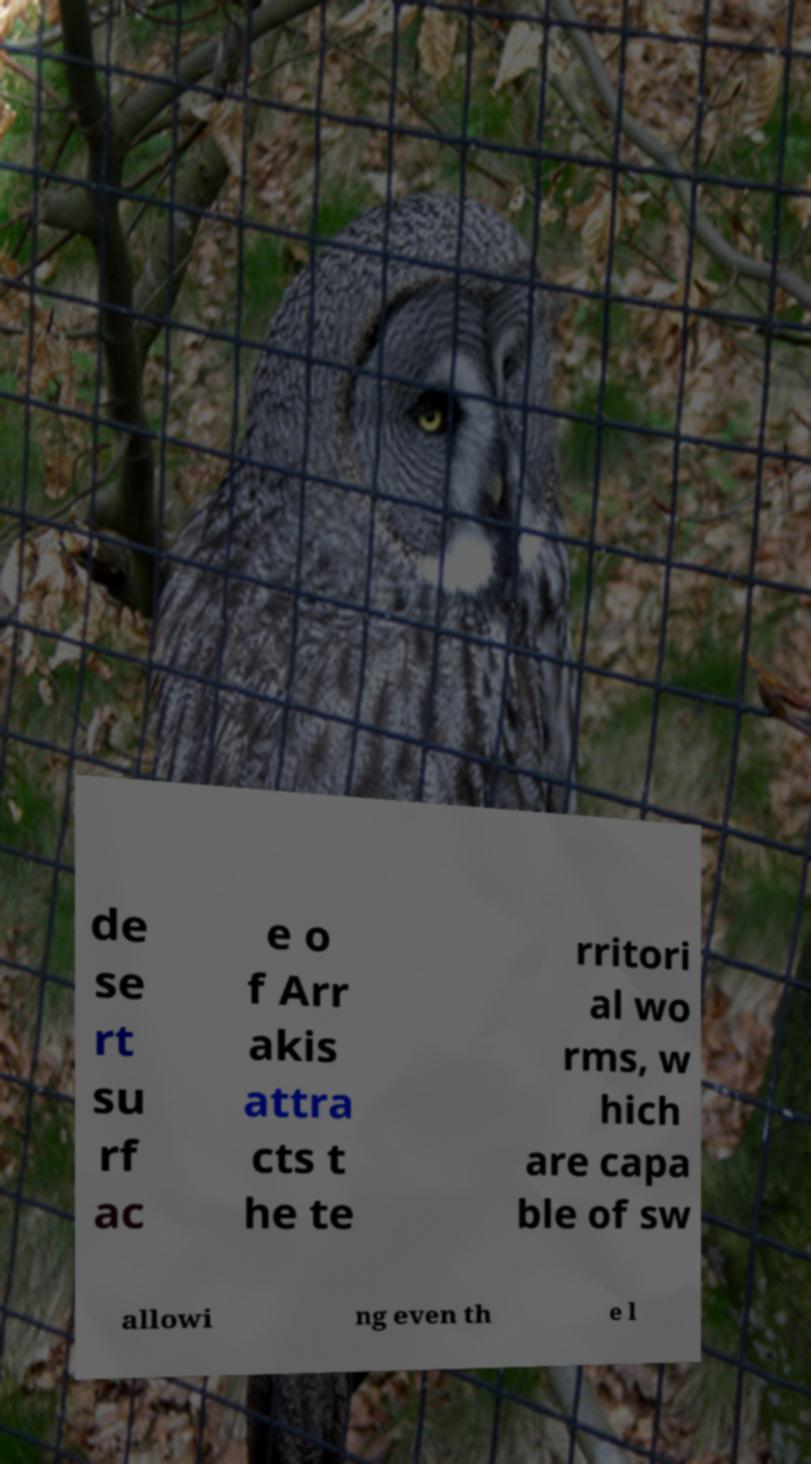What messages or text are displayed in this image? I need them in a readable, typed format. de se rt su rf ac e o f Arr akis attra cts t he te rritori al wo rms, w hich are capa ble of sw allowi ng even th e l 